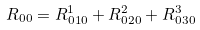Convert formula to latex. <formula><loc_0><loc_0><loc_500><loc_500>R _ { 0 0 } = R ^ { 1 } _ { 0 1 0 } + R ^ { 2 } _ { 0 2 0 } + R ^ { 3 } _ { 0 3 0 }</formula> 